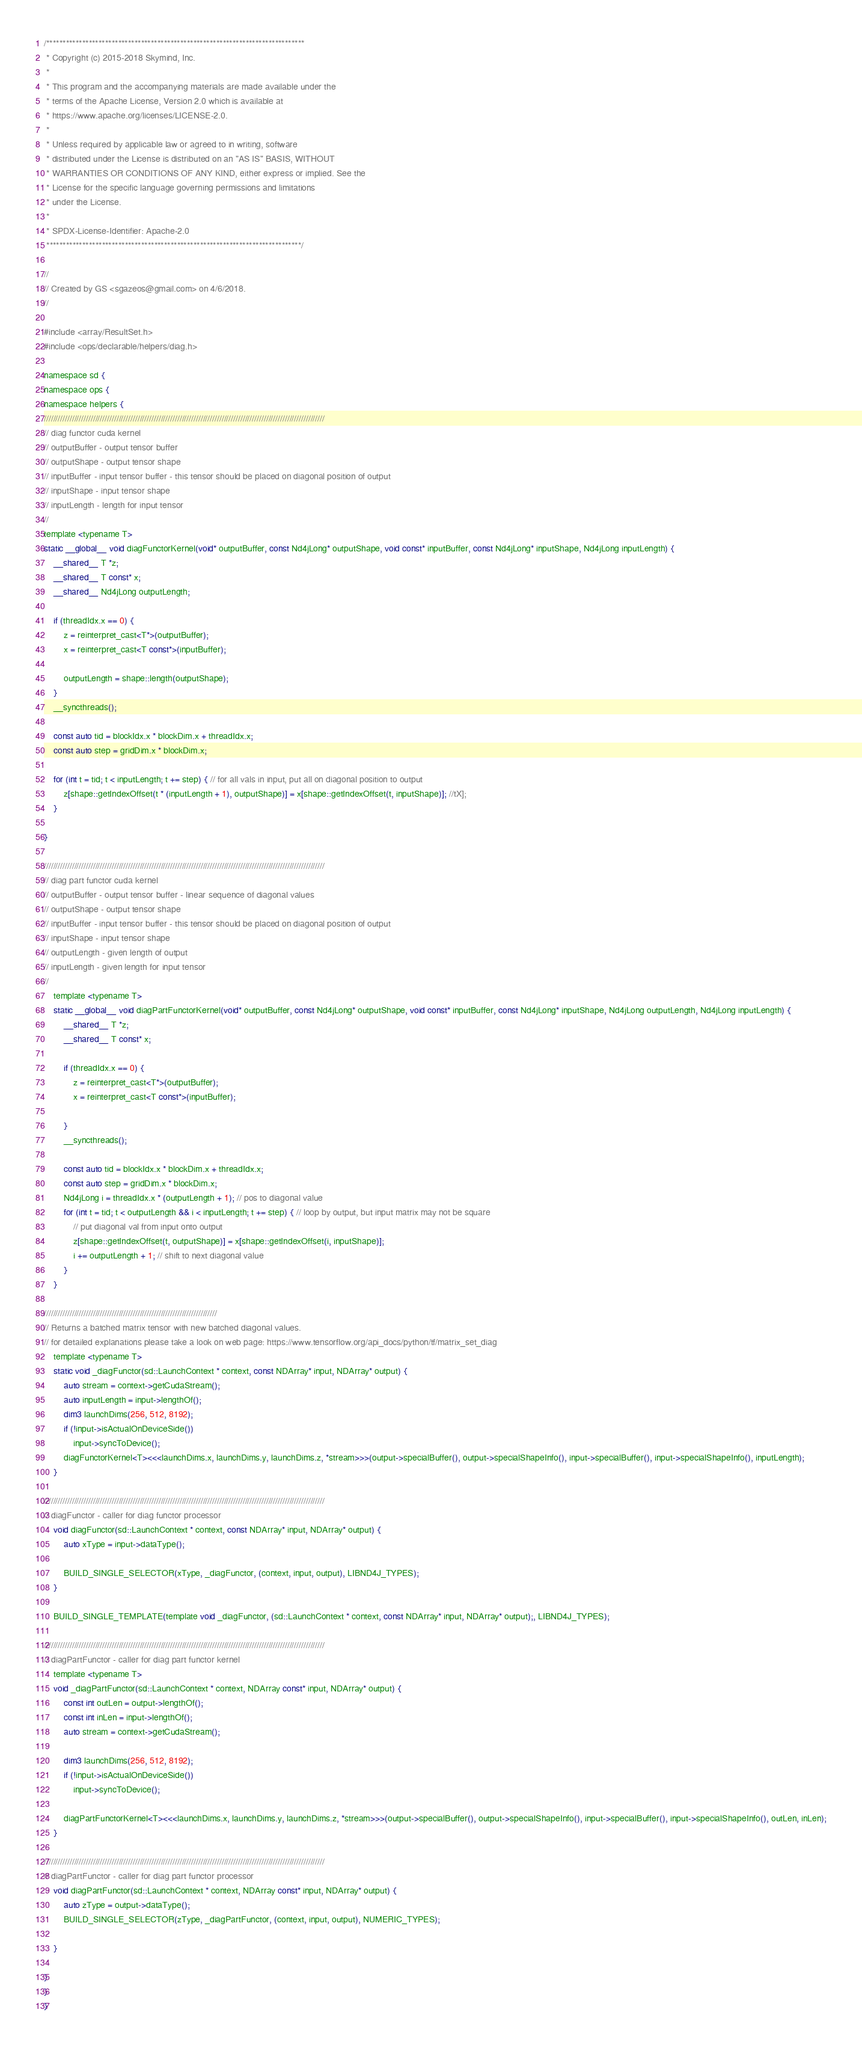Convert code to text. <code><loc_0><loc_0><loc_500><loc_500><_Cuda_>/*******************************************************************************
 * Copyright (c) 2015-2018 Skymind, Inc.
 *
 * This program and the accompanying materials are made available under the
 * terms of the Apache License, Version 2.0 which is available at
 * https://www.apache.org/licenses/LICENSE-2.0.
 *
 * Unless required by applicable law or agreed to in writing, software
 * distributed under the License is distributed on an "AS IS" BASIS, WITHOUT
 * WARRANTIES OR CONDITIONS OF ANY KIND, either express or implied. See the
 * License for the specific language governing permissions and limitations
 * under the License.
 *
 * SPDX-License-Identifier: Apache-2.0
 ******************************************************************************/

//
// Created by GS <sgazeos@gmail.com> on 4/6/2018.
//

#include <array/ResultSet.h>
#include <ops/declarable/helpers/diag.h>

namespace sd {
namespace ops {
namespace helpers {
////////////////////////////////////////////////////////////////////////////////////////////////////////////////////////
// diag functor cuda kernel
// outputBuffer - output tensor buffer
// outputShape - output tensor shape
// inputBuffer - input tensor buffer - this tensor should be placed on diagonal position of output
// inputShape - input tensor shape
// inputLength - length for input tensor
//
template <typename T>
static __global__ void diagFunctorKernel(void* outputBuffer, const Nd4jLong* outputShape, void const* inputBuffer, const Nd4jLong* inputShape, Nd4jLong inputLength) {
    __shared__ T *z;
    __shared__ T const* x;
    __shared__ Nd4jLong outputLength;

    if (threadIdx.x == 0) {
        z = reinterpret_cast<T*>(outputBuffer);
        x = reinterpret_cast<T const*>(inputBuffer);

        outputLength = shape::length(outputShape);
    }
    __syncthreads();

    const auto tid = blockIdx.x * blockDim.x + threadIdx.x;
    const auto step = gridDim.x * blockDim.x;

    for (int t = tid; t < inputLength; t += step) { // for all vals in input, put all on diagonal position to output
        z[shape::getIndexOffset(t * (inputLength + 1), outputShape)] = x[shape::getIndexOffset(t, inputShape)]; //tX];
    }

}

////////////////////////////////////////////////////////////////////////////////////////////////////////////////////////
// diag part functor cuda kernel
// outputBuffer - output tensor buffer - linear sequence of diagonal values
// outputShape - output tensor shape
// inputBuffer - input tensor buffer - this tensor should be placed on diagonal position of output
// inputShape - input tensor shape
// outputLength - given length of output
// inputLength - given length for input tensor
//
    template <typename T>
    static __global__ void diagPartFunctorKernel(void* outputBuffer, const Nd4jLong* outputShape, void const* inputBuffer, const Nd4jLong* inputShape, Nd4jLong outputLength, Nd4jLong inputLength) {
        __shared__ T *z;
        __shared__ T const* x;

        if (threadIdx.x == 0) {
            z = reinterpret_cast<T*>(outputBuffer);
            x = reinterpret_cast<T const*>(inputBuffer);

        }
        __syncthreads();

        const auto tid = blockIdx.x * blockDim.x + threadIdx.x;
        const auto step = gridDim.x * blockDim.x;
        Nd4jLong i = threadIdx.x * (outputLength + 1); // pos to diagonal value
        for (int t = tid; t < outputLength && i < inputLength; t += step) { // loop by output, but input matrix may not be square
            // put diagonal val from input onto output
            z[shape::getIndexOffset(t, outputShape)] = x[shape::getIndexOffset(i, inputShape)]; 
            i += outputLength + 1; // shift to next diagonal value
        }
    }

//////////////////////////////////////////////////////////////////////////
// Returns a batched matrix tensor with new batched diagonal values.
// for detailed explanations please take a look on web page: https://www.tensorflow.org/api_docs/python/tf/matrix_set_diag
    template <typename T>
    static void _diagFunctor(sd::LaunchContext * context, const NDArray* input, NDArray* output) {
        auto stream = context->getCudaStream();
        auto inputLength = input->lengthOf();
        dim3 launchDims(256, 512, 8192);
        if (!input->isActualOnDeviceSide())
            input->syncToDevice();
        diagFunctorKernel<T><<<launchDims.x, launchDims.y, launchDims.z, *stream>>>(output->specialBuffer(), output->specialShapeInfo(), input->specialBuffer(), input->specialShapeInfo(), inputLength);
    }

////////////////////////////////////////////////////////////////////////////////////////////////////////////////////////
// diagFunctor - caller for diag functor processor
    void diagFunctor(sd::LaunchContext * context, const NDArray* input, NDArray* output) {
        auto xType = input->dataType();

        BUILD_SINGLE_SELECTOR(xType, _diagFunctor, (context, input, output), LIBND4J_TYPES);
    }

    BUILD_SINGLE_TEMPLATE(template void _diagFunctor, (sd::LaunchContext * context, const NDArray* input, NDArray* output);, LIBND4J_TYPES);

////////////////////////////////////////////////////////////////////////////////////////////////////////////////////////
// diagPartFunctor - caller for diag part functor kernel
    template <typename T>
    void _diagPartFunctor(sd::LaunchContext * context, NDArray const* input, NDArray* output) {
        const int outLen = output->lengthOf();
        const int inLen = input->lengthOf();
        auto stream = context->getCudaStream();

        dim3 launchDims(256, 512, 8192);
        if (!input->isActualOnDeviceSide())
            input->syncToDevice();

        diagPartFunctorKernel<T><<<launchDims.x, launchDims.y, launchDims.z, *stream>>>(output->specialBuffer(), output->specialShapeInfo(), input->specialBuffer(), input->specialShapeInfo(), outLen, inLen);
    }

////////////////////////////////////////////////////////////////////////////////////////////////////////////////////////
// diagPartFunctor - caller for diag part functor processor
    void diagPartFunctor(sd::LaunchContext * context, NDArray const* input, NDArray* output) {
        auto zType = output->dataType();
        BUILD_SINGLE_SELECTOR(zType, _diagPartFunctor, (context, input, output), NUMERIC_TYPES);

    }

}
}
}</code> 